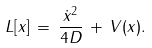Convert formula to latex. <formula><loc_0><loc_0><loc_500><loc_500>L [ x ] \, = \, \frac { \dot { x } ^ { 2 } } { 4 D } \, + \, V ( x ) .</formula> 